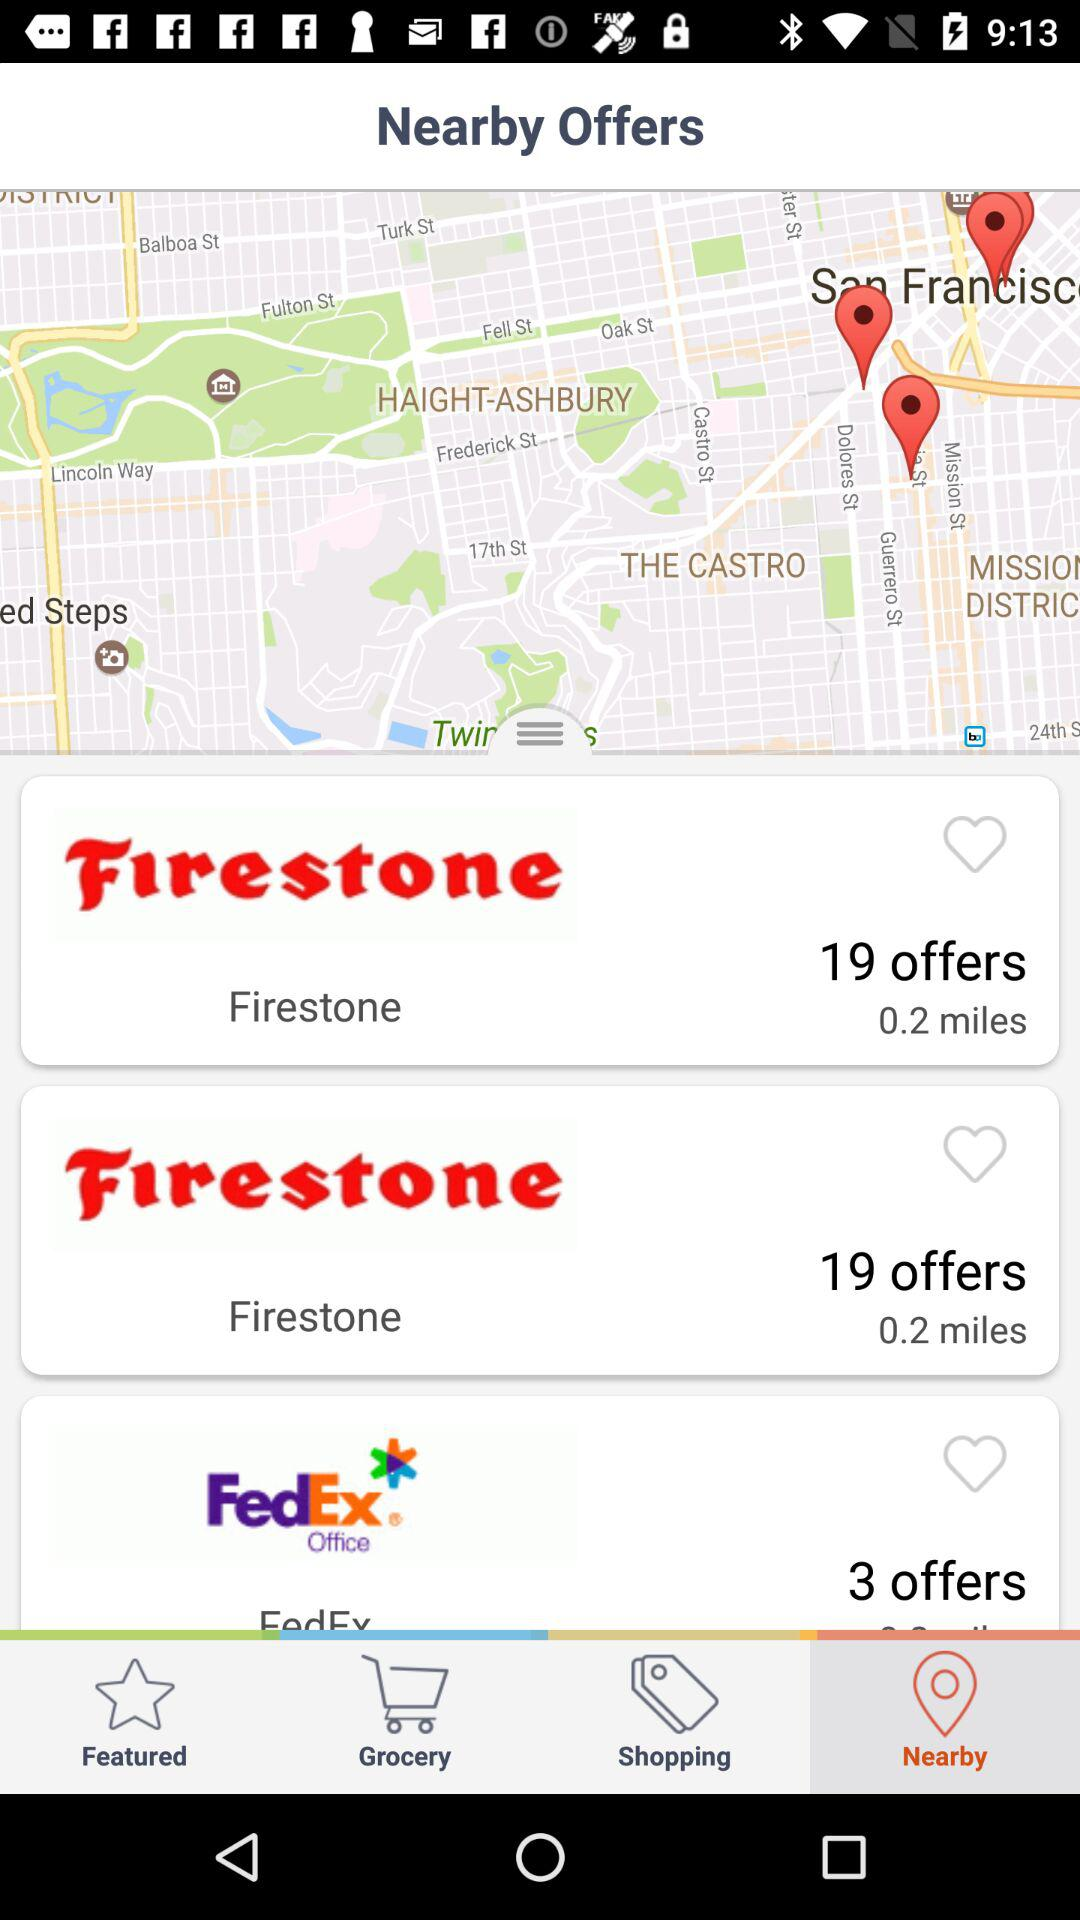How far is "Firestone"? "Firestone" is 0.2 miles away. 